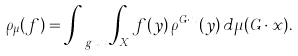Convert formula to latex. <formula><loc_0><loc_0><loc_500><loc_500>\rho _ { \mu } ( f ) = \int _ { \ g u x } \int _ { X } f ( y ) \, \rho ^ { G \cdot x } ( y ) \, d \mu ( G \cdot x ) .</formula> 